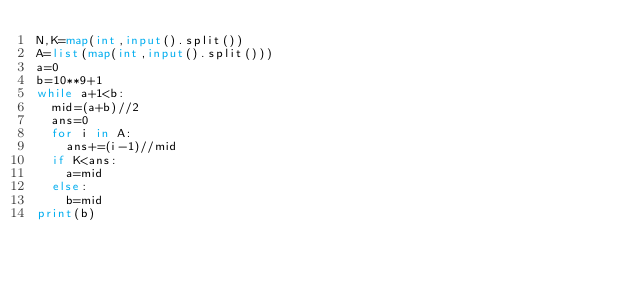Convert code to text. <code><loc_0><loc_0><loc_500><loc_500><_Python_>N,K=map(int,input().split())
A=list(map(int,input().split()))
a=0
b=10**9+1
while a+1<b:
  mid=(a+b)//2
  ans=0
  for i in A:
    ans+=(i-1)//mid
  if K<ans:
    a=mid
  else:
    b=mid
print(b)</code> 